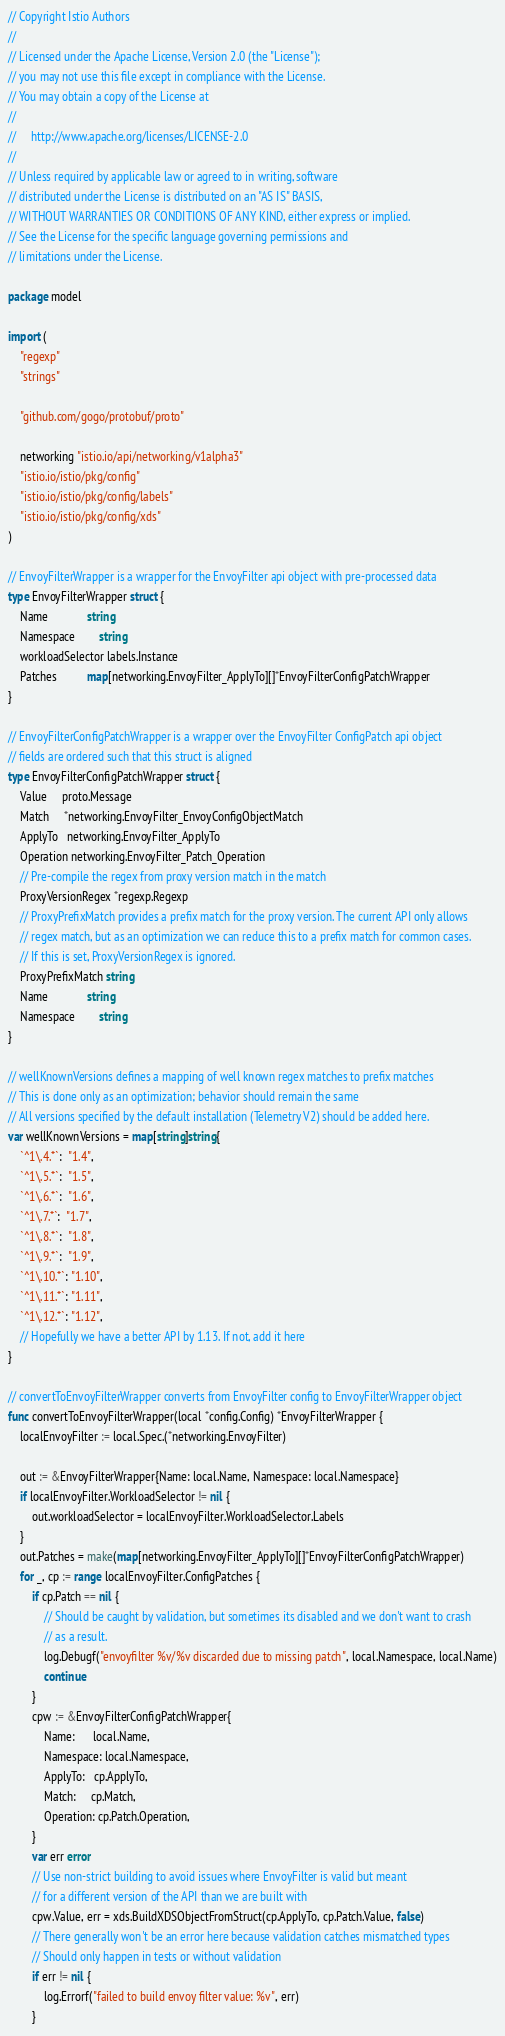Convert code to text. <code><loc_0><loc_0><loc_500><loc_500><_Go_>// Copyright Istio Authors
//
// Licensed under the Apache License, Version 2.0 (the "License");
// you may not use this file except in compliance with the License.
// You may obtain a copy of the License at
//
//     http://www.apache.org/licenses/LICENSE-2.0
//
// Unless required by applicable law or agreed to in writing, software
// distributed under the License is distributed on an "AS IS" BASIS,
// WITHOUT WARRANTIES OR CONDITIONS OF ANY KIND, either express or implied.
// See the License for the specific language governing permissions and
// limitations under the License.

package model

import (
	"regexp"
	"strings"

	"github.com/gogo/protobuf/proto"

	networking "istio.io/api/networking/v1alpha3"
	"istio.io/istio/pkg/config"
	"istio.io/istio/pkg/config/labels"
	"istio.io/istio/pkg/config/xds"
)

// EnvoyFilterWrapper is a wrapper for the EnvoyFilter api object with pre-processed data
type EnvoyFilterWrapper struct {
	Name             string
	Namespace        string
	workloadSelector labels.Instance
	Patches          map[networking.EnvoyFilter_ApplyTo][]*EnvoyFilterConfigPatchWrapper
}

// EnvoyFilterConfigPatchWrapper is a wrapper over the EnvoyFilter ConfigPatch api object
// fields are ordered such that this struct is aligned
type EnvoyFilterConfigPatchWrapper struct {
	Value     proto.Message
	Match     *networking.EnvoyFilter_EnvoyConfigObjectMatch
	ApplyTo   networking.EnvoyFilter_ApplyTo
	Operation networking.EnvoyFilter_Patch_Operation
	// Pre-compile the regex from proxy version match in the match
	ProxyVersionRegex *regexp.Regexp
	// ProxyPrefixMatch provides a prefix match for the proxy version. The current API only allows
	// regex match, but as an optimization we can reduce this to a prefix match for common cases.
	// If this is set, ProxyVersionRegex is ignored.
	ProxyPrefixMatch string
	Name             string
	Namespace        string
}

// wellKnownVersions defines a mapping of well known regex matches to prefix matches
// This is done only as an optimization; behavior should remain the same
// All versions specified by the default installation (Telemetry V2) should be added here.
var wellKnownVersions = map[string]string{
	`^1\.4.*`:  "1.4",
	`^1\.5.*`:  "1.5",
	`^1\.6.*`:  "1.6",
	`^1\.7.*`:  "1.7",
	`^1\.8.*`:  "1.8",
	`^1\.9.*`:  "1.9",
	`^1\.10.*`: "1.10",
	`^1\.11.*`: "1.11",
	`^1\.12.*`: "1.12",
	// Hopefully we have a better API by 1.13. If not, add it here
}

// convertToEnvoyFilterWrapper converts from EnvoyFilter config to EnvoyFilterWrapper object
func convertToEnvoyFilterWrapper(local *config.Config) *EnvoyFilterWrapper {
	localEnvoyFilter := local.Spec.(*networking.EnvoyFilter)

	out := &EnvoyFilterWrapper{Name: local.Name, Namespace: local.Namespace}
	if localEnvoyFilter.WorkloadSelector != nil {
		out.workloadSelector = localEnvoyFilter.WorkloadSelector.Labels
	}
	out.Patches = make(map[networking.EnvoyFilter_ApplyTo][]*EnvoyFilterConfigPatchWrapper)
	for _, cp := range localEnvoyFilter.ConfigPatches {
		if cp.Patch == nil {
			// Should be caught by validation, but sometimes its disabled and we don't want to crash
			// as a result.
			log.Debugf("envoyfilter %v/%v discarded due to missing patch", local.Namespace, local.Name)
			continue
		}
		cpw := &EnvoyFilterConfigPatchWrapper{
			Name:      local.Name,
			Namespace: local.Namespace,
			ApplyTo:   cp.ApplyTo,
			Match:     cp.Match,
			Operation: cp.Patch.Operation,
		}
		var err error
		// Use non-strict building to avoid issues where EnvoyFilter is valid but meant
		// for a different version of the API than we are built with
		cpw.Value, err = xds.BuildXDSObjectFromStruct(cp.ApplyTo, cp.Patch.Value, false)
		// There generally won't be an error here because validation catches mismatched types
		// Should only happen in tests or without validation
		if err != nil {
			log.Errorf("failed to build envoy filter value: %v", err)
		}</code> 